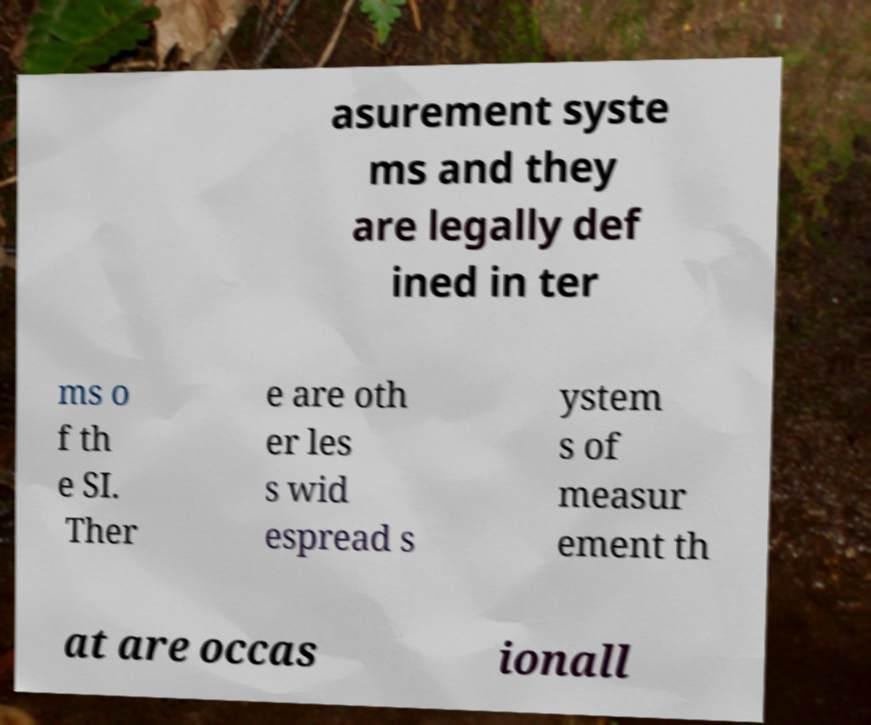Could you assist in decoding the text presented in this image and type it out clearly? asurement syste ms and they are legally def ined in ter ms o f th e SI. Ther e are oth er les s wid espread s ystem s of measur ement th at are occas ionall 